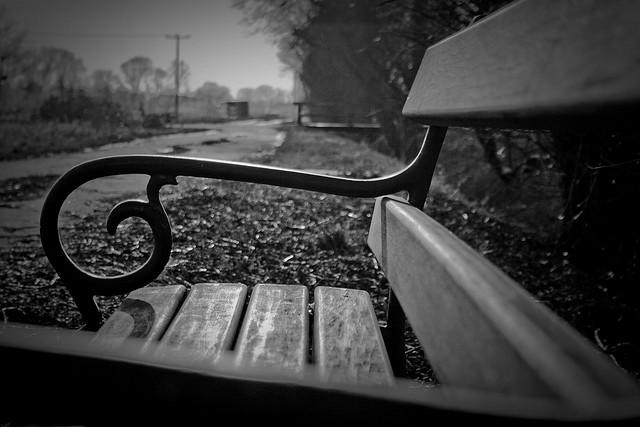Is that a burning barrel in the background?
Answer briefly. No. Does the bench have straight arms?
Answer briefly. No. Is anyone sitting here?
Quick response, please. No. 